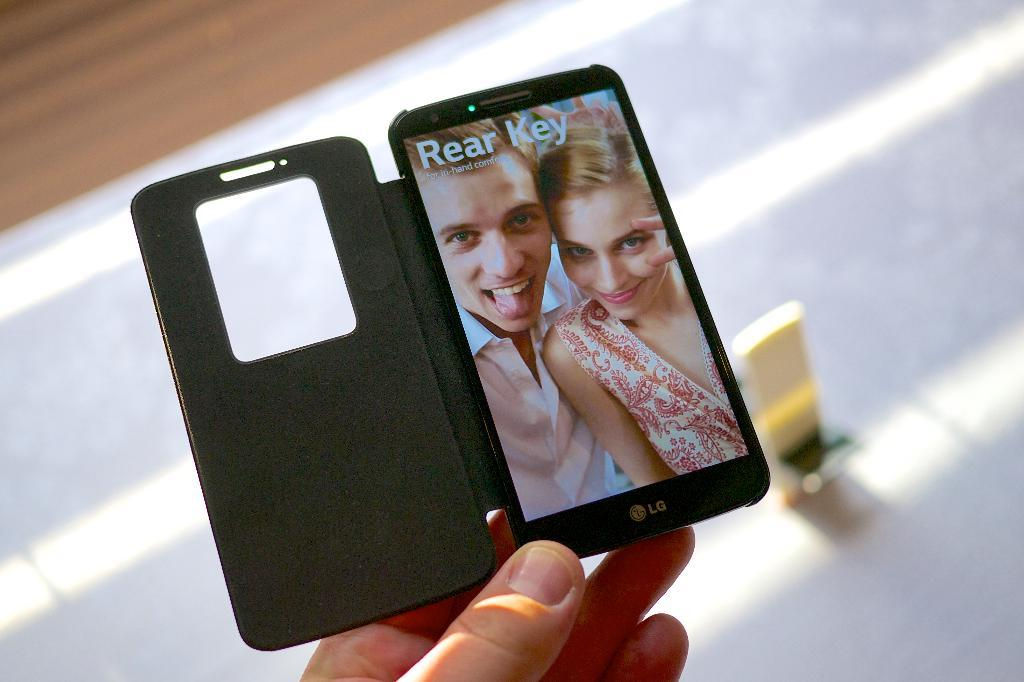<image>
Offer a succinct explanation of the picture presented. A person holding an LG brand phone with a photo of a couple posing and the words Rear Key above 